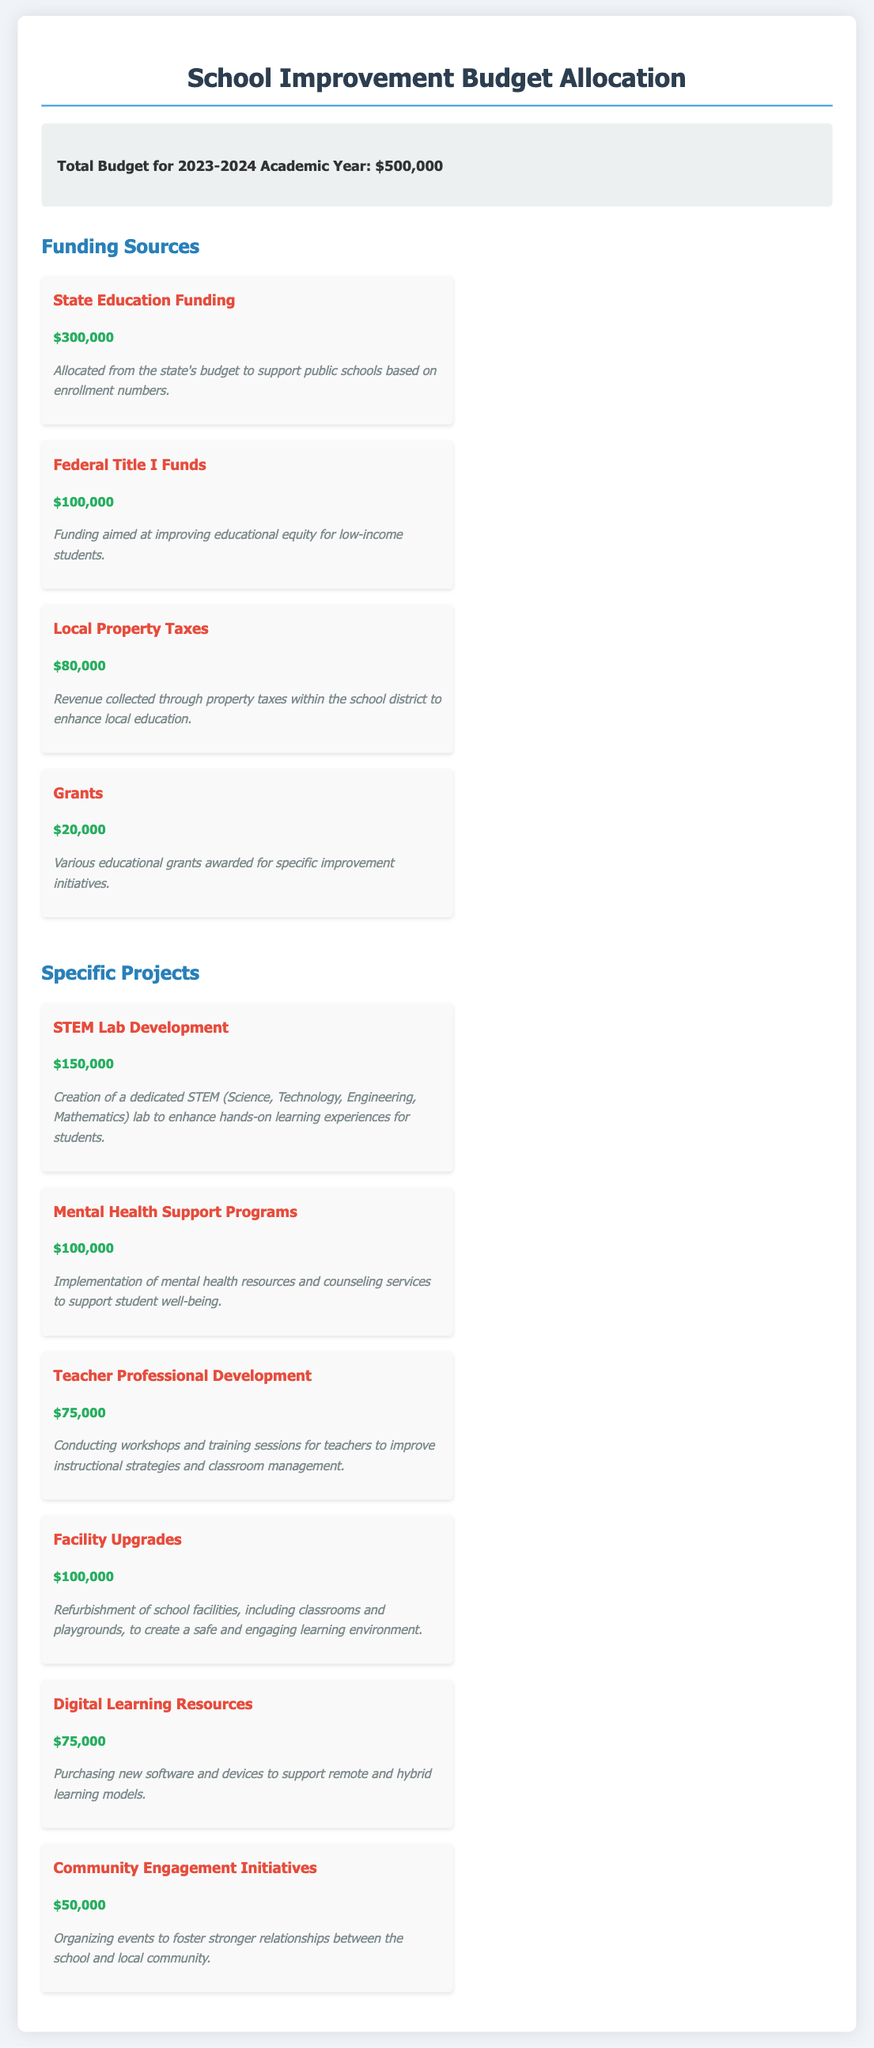What is the total budget for the 2023-2024 academic year? The total budget is clearly stated in the document under the budget overview section.
Answer: $500,000 How much funding is allocated from State Education Funding? This amount is specifically mentioned in the funding sources section of the document.
Answer: $300,000 What is the purpose of the Federal Title I Funds? The description explicitly states the aim of these funds within the document.
Answer: Improving educational equity for low-income students What specific project receives the highest funding? By comparing the amounts allocated to each project listed, we find the project with the highest funding.
Answer: STEM Lab Development How much is allocated for Mental Health Support Programs? The funding amount for this specific project is explicitly detailed in the projects section.
Answer: $100,000 What percentage of the total budget is allocated to Facility Upgrades? To calculate this, take the funding amount for Facility Upgrades and divide it by the total budget, then multiply by 100.
Answer: 20% How many funding sources are listed in the document? A count of the different funding sources will give the required number mentioned in the document.
Answer: 4 What is the total allocated for Community Engagement Initiatives? The exact funding amount for this project is stated in the specific projects section.
Answer: $50,000 What percentage of the total budget is allocated for Teacher Professional Development? Calculate this by taking the funding amount for Teacher Professional Development and dividing it by the total budget, then multiplying by 100.
Answer: 15% 